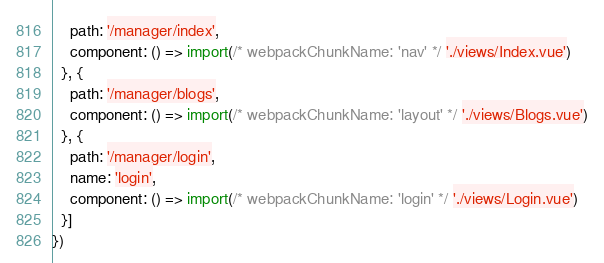Convert code to text. <code><loc_0><loc_0><loc_500><loc_500><_JavaScript_>    path: '/manager/index',
    component: () => import(/* webpackChunkName: 'nav' */ './views/Index.vue')
  }, {
    path: '/manager/blogs',
    component: () => import(/* webpackChunkName: 'layout' */ './views/Blogs.vue')
  }, {
    path: '/manager/login',
    name: 'login',
    component: () => import(/* webpackChunkName: 'login' */ './views/Login.vue')
  }]
})
</code> 